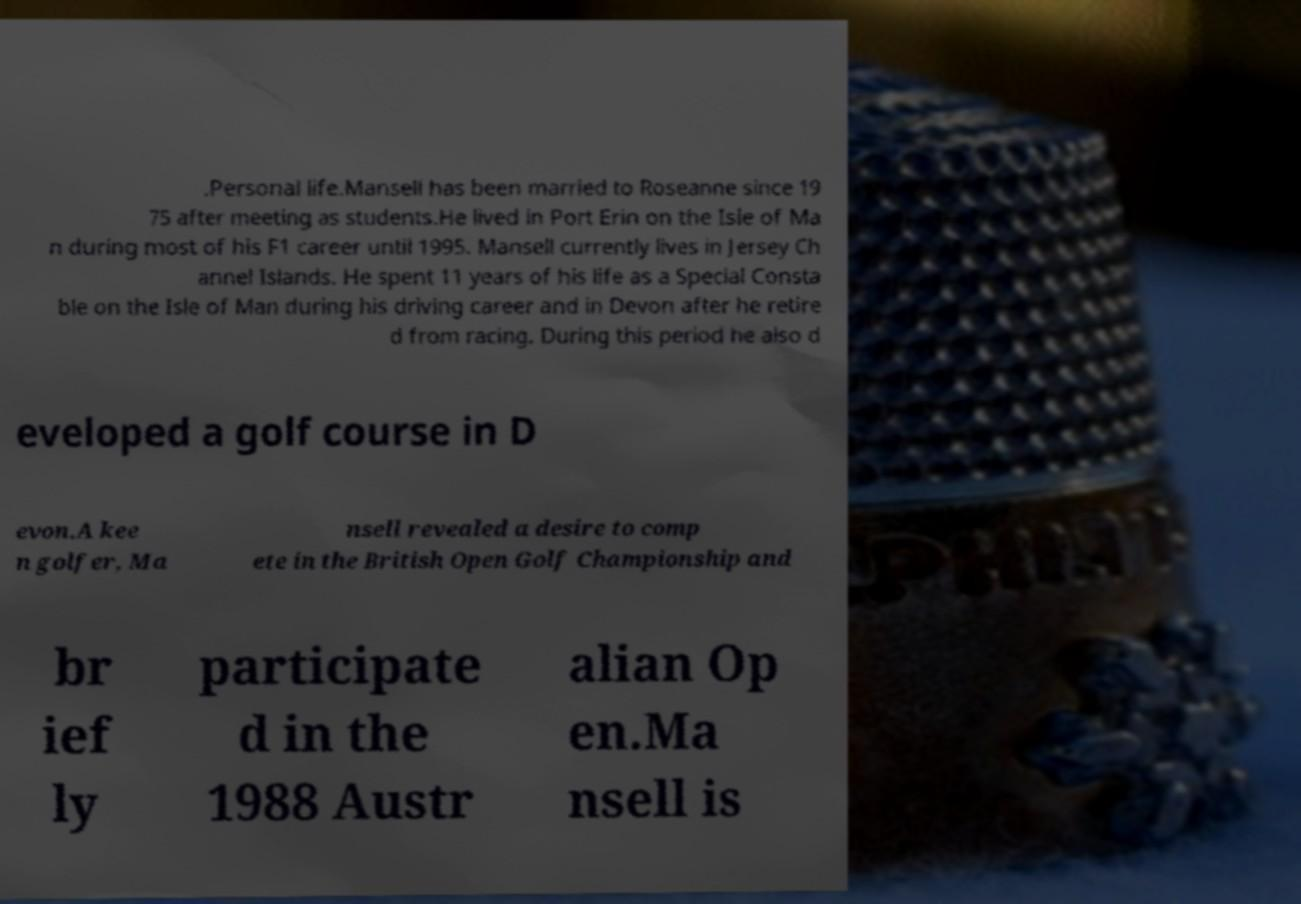Please identify and transcribe the text found in this image. .Personal life.Mansell has been married to Roseanne since 19 75 after meeting as students.He lived in Port Erin on the Isle of Ma n during most of his F1 career until 1995. Mansell currently lives in Jersey Ch annel Islands. He spent 11 years of his life as a Special Consta ble on the Isle of Man during his driving career and in Devon after he retire d from racing. During this period he also d eveloped a golf course in D evon.A kee n golfer, Ma nsell revealed a desire to comp ete in the British Open Golf Championship and br ief ly participate d in the 1988 Austr alian Op en.Ma nsell is 